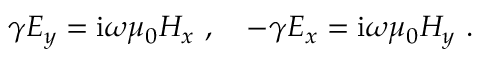Convert formula to latex. <formula><loc_0><loc_0><loc_500><loc_500>\gamma E _ { y } = i \omega \mu _ { 0 } H _ { x } \ , \quad - \gamma E _ { x } = i \omega \mu _ { 0 } H _ { y } \ .</formula> 